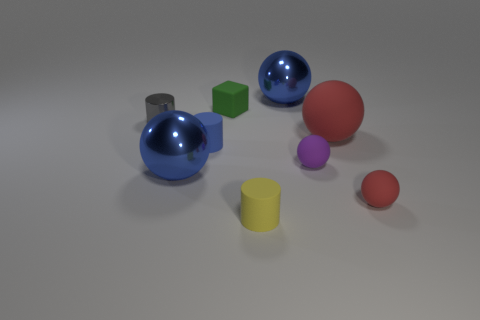Subtract all small balls. How many balls are left? 3 Add 1 small purple rubber cubes. How many objects exist? 10 Subtract all blue cylinders. How many cylinders are left? 2 Subtract 3 spheres. How many spheres are left? 2 Add 9 tiny cyan rubber spheres. How many tiny cyan rubber spheres exist? 9 Subtract 1 blue cylinders. How many objects are left? 8 Subtract all balls. How many objects are left? 4 Subtract all gray cylinders. Subtract all purple blocks. How many cylinders are left? 2 Subtract all red blocks. How many blue cylinders are left? 1 Subtract all small matte objects. Subtract all big red rubber objects. How many objects are left? 3 